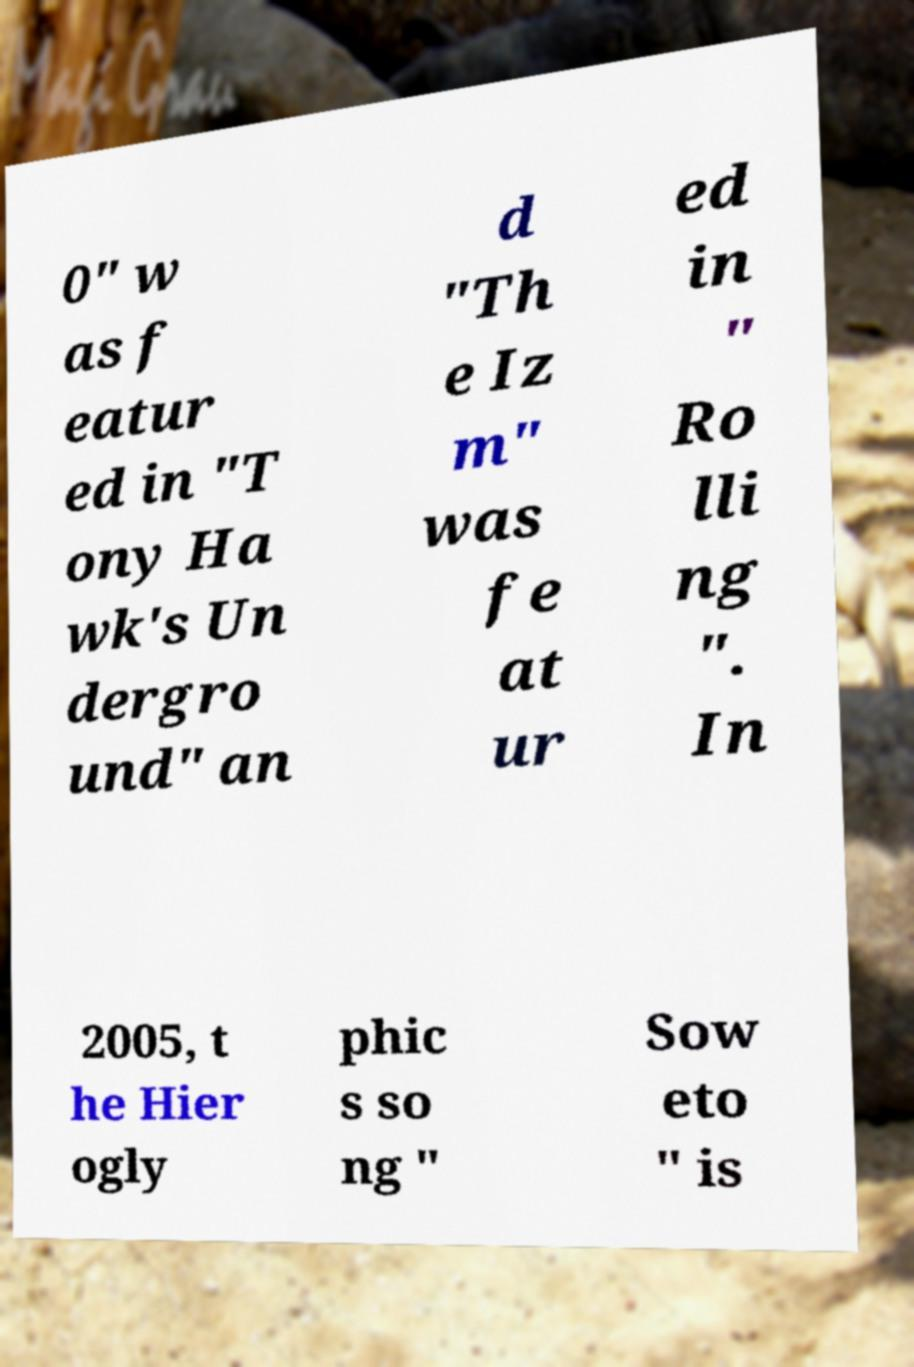Could you assist in decoding the text presented in this image and type it out clearly? 0" w as f eatur ed in "T ony Ha wk's Un dergro und" an d "Th e Iz m" was fe at ur ed in " Ro lli ng ". In 2005, t he Hier ogly phic s so ng " Sow eto " is 